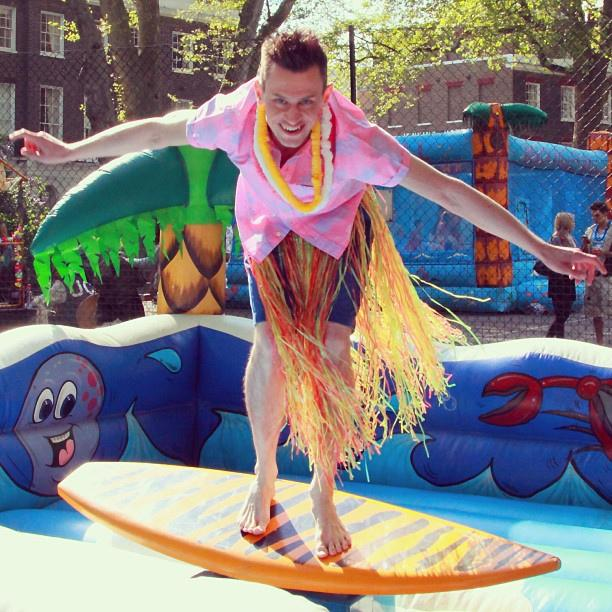What kind of animal is the cartoon face on the left? octopus 